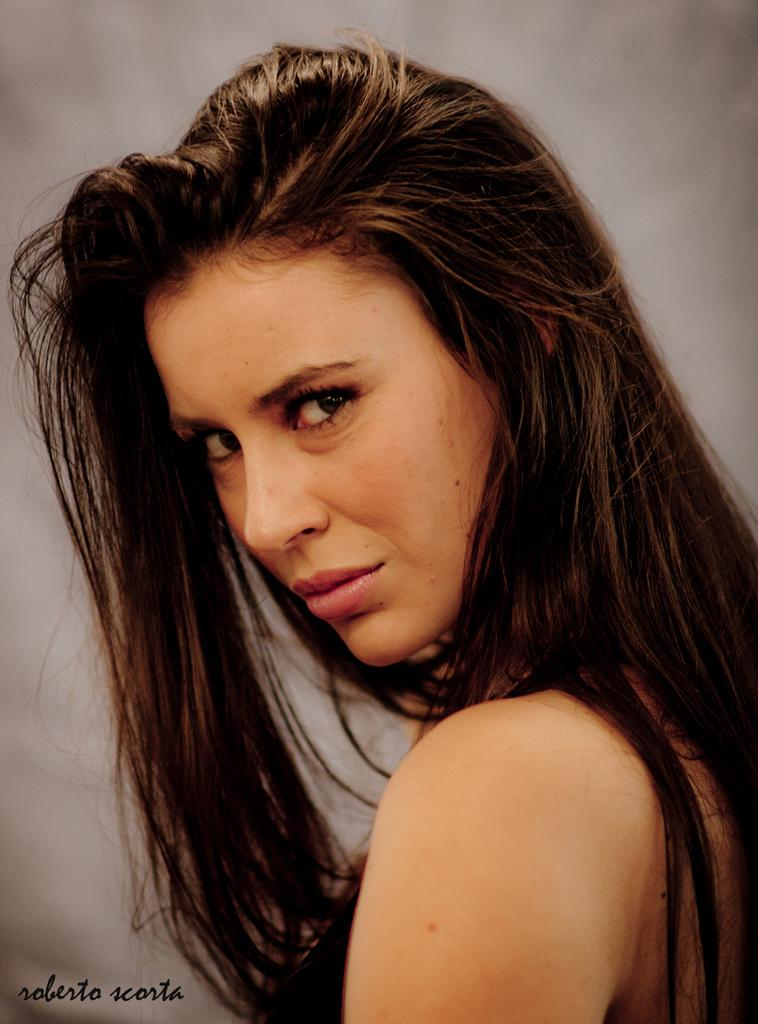Who is present in the image? There is a woman in the image. Can you describe any additional features of the image? The image has a watermark in the bottom left corner, and the background of the image is blurred. What type of pie is being served on the brass plate in the image? There is no pie or brass plate present in the image. 